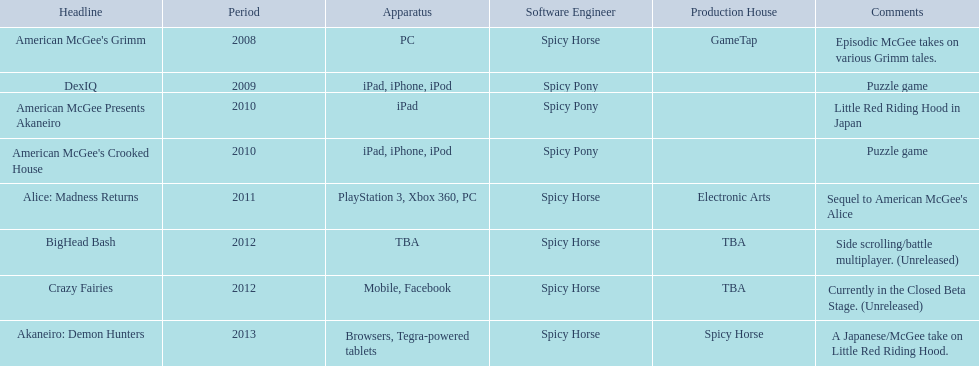What spicy horse titles are listed? American McGee's Grimm, DexIQ, American McGee Presents Akaneiro, American McGee's Crooked House, Alice: Madness Returns, BigHead Bash, Crazy Fairies, Akaneiro: Demon Hunters. Which of these can be used on ipad? DexIQ, American McGee Presents Akaneiro, American McGee's Crooked House. Which left cannot also be used on iphone or ipod? American McGee Presents Akaneiro. 